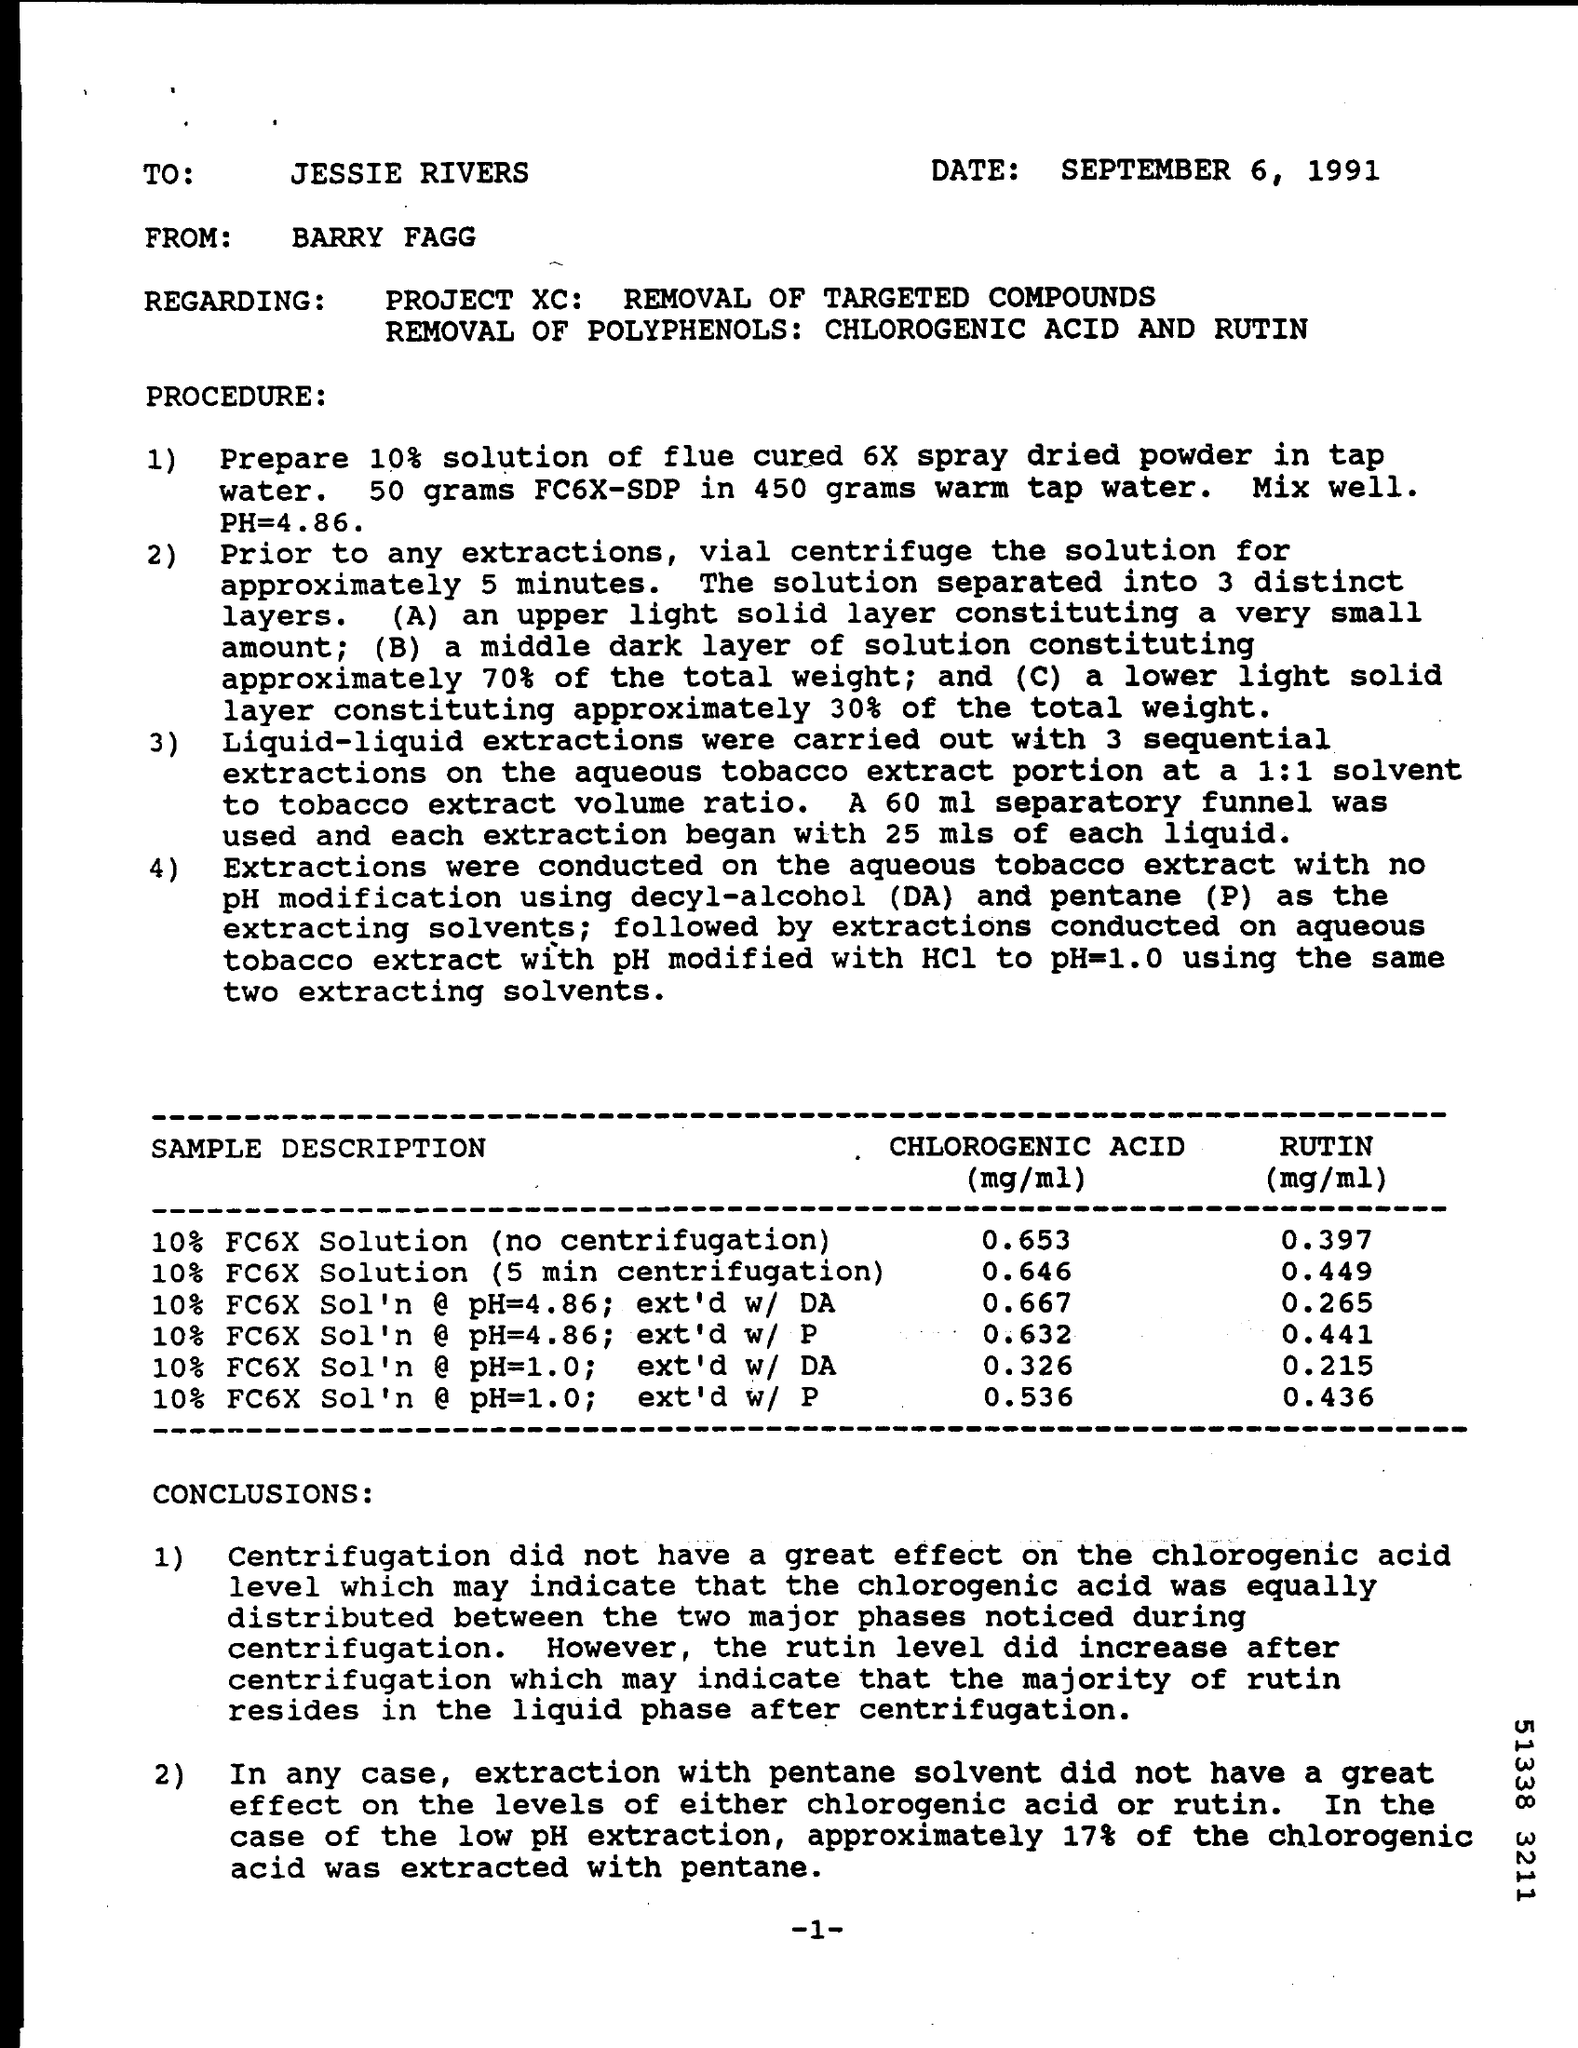Specify some key components in this picture. The letter was written to Jessie Rivers. The date mentioned in the given letter is September 6, 1991. 